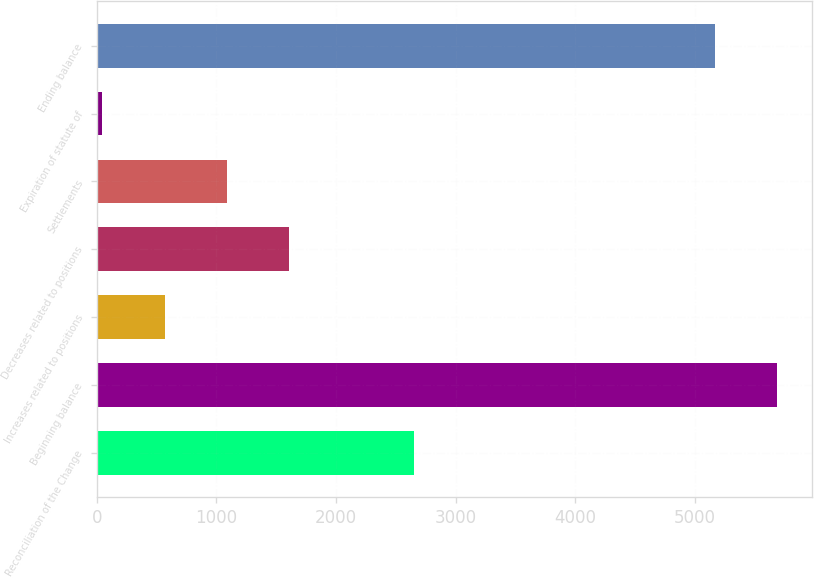Convert chart. <chart><loc_0><loc_0><loc_500><loc_500><bar_chart><fcel>Reconciliation of the Change<fcel>Beginning balance<fcel>Increases related to positions<fcel>Decreases related to positions<fcel>Settlements<fcel>Expiration of statute of<fcel>Ending balance<nl><fcel>2651<fcel>5689.4<fcel>569.4<fcel>1610.2<fcel>1089.8<fcel>49<fcel>5169<nl></chart> 